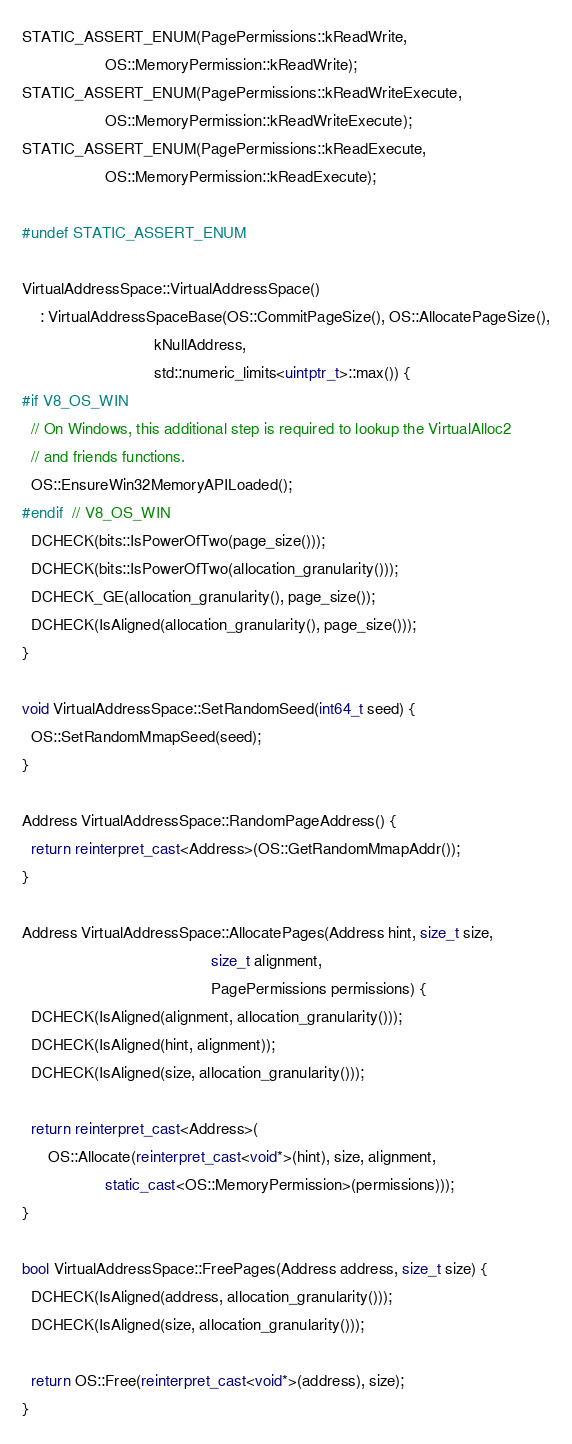Convert code to text. <code><loc_0><loc_0><loc_500><loc_500><_C++_>STATIC_ASSERT_ENUM(PagePermissions::kReadWrite,
                   OS::MemoryPermission::kReadWrite);
STATIC_ASSERT_ENUM(PagePermissions::kReadWriteExecute,
                   OS::MemoryPermission::kReadWriteExecute);
STATIC_ASSERT_ENUM(PagePermissions::kReadExecute,
                   OS::MemoryPermission::kReadExecute);

#undef STATIC_ASSERT_ENUM

VirtualAddressSpace::VirtualAddressSpace()
    : VirtualAddressSpaceBase(OS::CommitPageSize(), OS::AllocatePageSize(),
                              kNullAddress,
                              std::numeric_limits<uintptr_t>::max()) {
#if V8_OS_WIN
  // On Windows, this additional step is required to lookup the VirtualAlloc2
  // and friends functions.
  OS::EnsureWin32MemoryAPILoaded();
#endif  // V8_OS_WIN
  DCHECK(bits::IsPowerOfTwo(page_size()));
  DCHECK(bits::IsPowerOfTwo(allocation_granularity()));
  DCHECK_GE(allocation_granularity(), page_size());
  DCHECK(IsAligned(allocation_granularity(), page_size()));
}

void VirtualAddressSpace::SetRandomSeed(int64_t seed) {
  OS::SetRandomMmapSeed(seed);
}

Address VirtualAddressSpace::RandomPageAddress() {
  return reinterpret_cast<Address>(OS::GetRandomMmapAddr());
}

Address VirtualAddressSpace::AllocatePages(Address hint, size_t size,
                                           size_t alignment,
                                           PagePermissions permissions) {
  DCHECK(IsAligned(alignment, allocation_granularity()));
  DCHECK(IsAligned(hint, alignment));
  DCHECK(IsAligned(size, allocation_granularity()));

  return reinterpret_cast<Address>(
      OS::Allocate(reinterpret_cast<void*>(hint), size, alignment,
                   static_cast<OS::MemoryPermission>(permissions)));
}

bool VirtualAddressSpace::FreePages(Address address, size_t size) {
  DCHECK(IsAligned(address, allocation_granularity()));
  DCHECK(IsAligned(size, allocation_granularity()));

  return OS::Free(reinterpret_cast<void*>(address), size);
}
</code> 